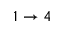<formula> <loc_0><loc_0><loc_500><loc_500>1 \to 4</formula> 